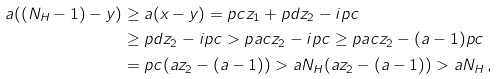Convert formula to latex. <formula><loc_0><loc_0><loc_500><loc_500>a ( ( N _ { H } - 1 ) - y ) & \geq a ( x - y ) = p c z _ { 1 } + p d z _ { 2 } - i p c \\ & \geq p d z _ { 2 } - i p c > p a c z _ { 2 } - i p c \geq p a c z _ { 2 } - ( a - 1 ) p c \\ & = p c ( a z _ { 2 } - ( a - 1 ) ) > a N _ { H } ( a z _ { 2 } - ( a - 1 ) ) > a N _ { H } \, ,</formula> 